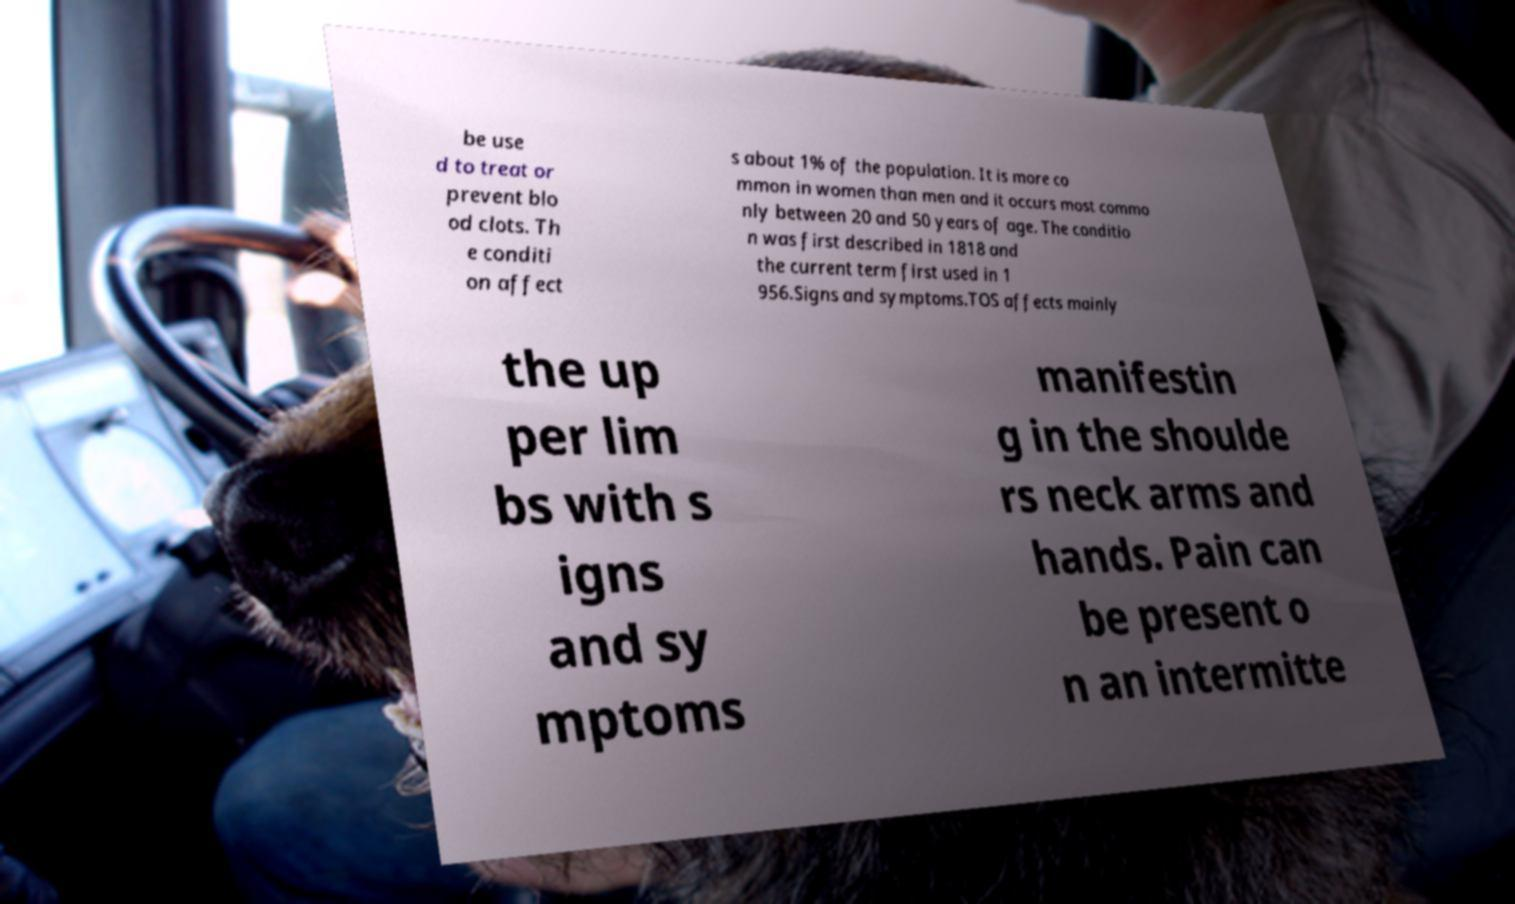Could you extract and type out the text from this image? be use d to treat or prevent blo od clots. Th e conditi on affect s about 1% of the population. It is more co mmon in women than men and it occurs most commo nly between 20 and 50 years of age. The conditio n was first described in 1818 and the current term first used in 1 956.Signs and symptoms.TOS affects mainly the up per lim bs with s igns and sy mptoms manifestin g in the shoulde rs neck arms and hands. Pain can be present o n an intermitte 